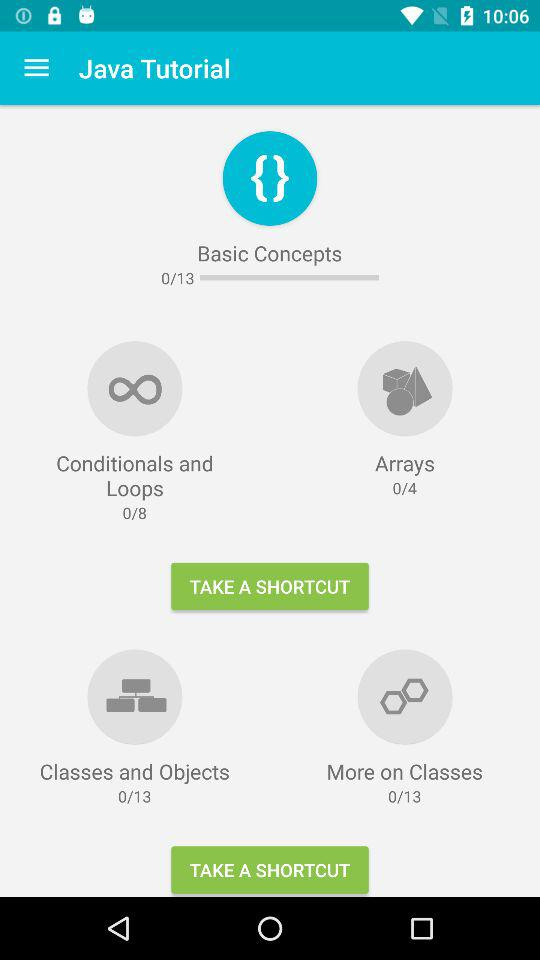How many "Classes and Objects" in "Java Tutorial" are there in total? There are 13 "Classes and Objects" in total. 